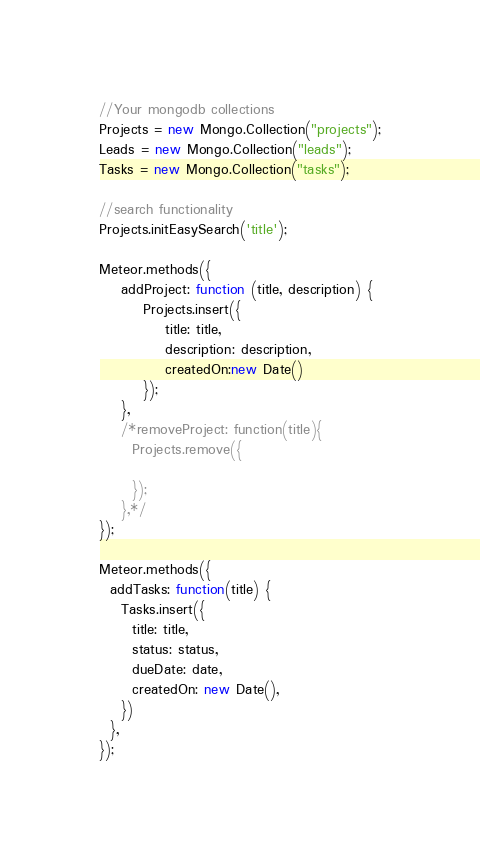<code> <loc_0><loc_0><loc_500><loc_500><_JavaScript_>//Your mongodb collections
Projects = new Mongo.Collection("projects");
Leads = new Mongo.Collection("leads");
Tasks = new Mongo.Collection("tasks");

//search functionality
Projects.initEasySearch('title');

Meteor.methods({
    addProject: function (title, description) {
        Projects.insert({
            title: title,
            description: description,
            createdOn:new Date()
        });
    },
    /*removeProject: function(title){
      Projects.remove({
        
      });
    },*/
});

Meteor.methods({
  addTasks: function(title) {
    Tasks.insert({
      title: title,
      status: status,
      dueDate: date,
      createdOn: new Date(),
    })
  },
});</code> 